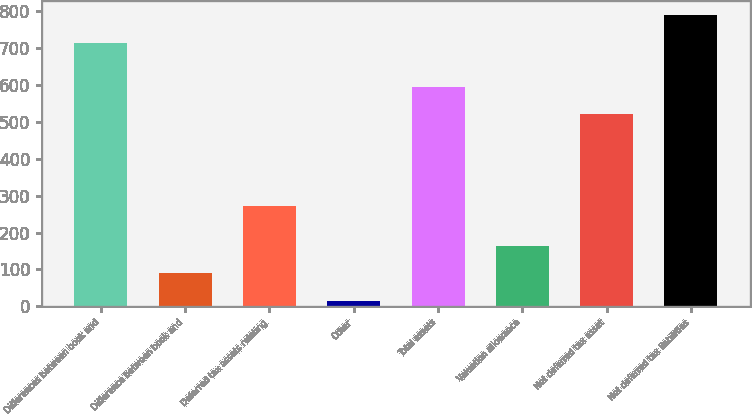Convert chart to OTSL. <chart><loc_0><loc_0><loc_500><loc_500><bar_chart><fcel>Differences between book and<fcel>Difference between book and<fcel>Deferred tax assets relating<fcel>Other<fcel>Total assets<fcel>Valuation allowance<fcel>Net deferred tax asset<fcel>Net deferred tax liabilities<nl><fcel>715.3<fcel>88.95<fcel>272.5<fcel>14.4<fcel>596<fcel>163.5<fcel>521.45<fcel>789.85<nl></chart> 